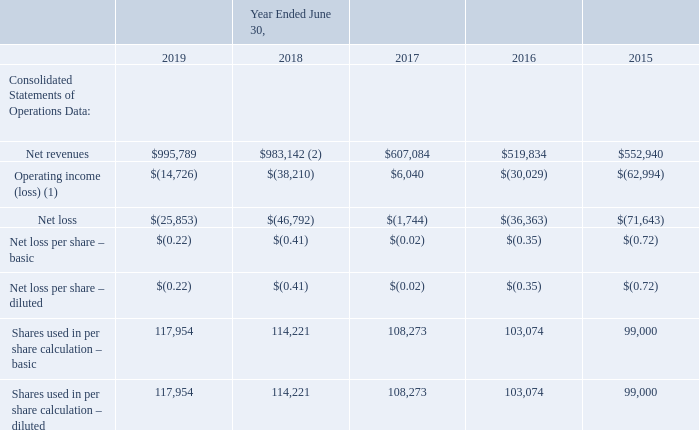Item 6. Selected Financial Data
The following table sets forth selected consolidated financial data for each of the fiscal years ended June 30, 2019, 2018, 2017, 2016 and 2015 derived from the Company’s audited financial statements (in thousands, except per share amounts). The consolidated financial data as of and for the years ended June 30, 2015 are derived from the audited financial statements which have not been adjusted for the adoption of Accounting Standards update 2014- 09, Revenue from Contracts with Customers (Topic 606). These tables should be reviewed in conjunction with the Consolidated Financial Statements in Item 8 and related Notes, as well as Item 7, “Management’s Discussion and Analysis of Financial Condition and Results of Operations.” Historical results may not be indicative of future results.
(1) Operating income (loss) include the following operating expenses (in thousands):
(2)  The significant increase in net revenues during the year ended June 30, 2018 was primarily due to the acquisitions of the Campus Fabric and Data Center Businesses.
Which years does the table provide information for the company's audited financial statements? 2019, 2018, 2017, 2016, 2015. What was the net revenues in 2015?
Answer scale should be: thousand. 552,940. What was the net loss in 2019?
Answer scale should be: thousand. (25,853). How many years did the net revenues exceed $700,000 thousand? 2019##2018
Answer: 2. What was the change in the basic shares used in per share calculation between 2017 and 2018?
Answer scale should be: thousand. 114,221-108,273
Answer: 5948. What was the percentage change in the basic net loss per share between 2018 and 2019?
Answer scale should be: percent. (-0.22+0.41)/-0.41
Answer: -46.34. 